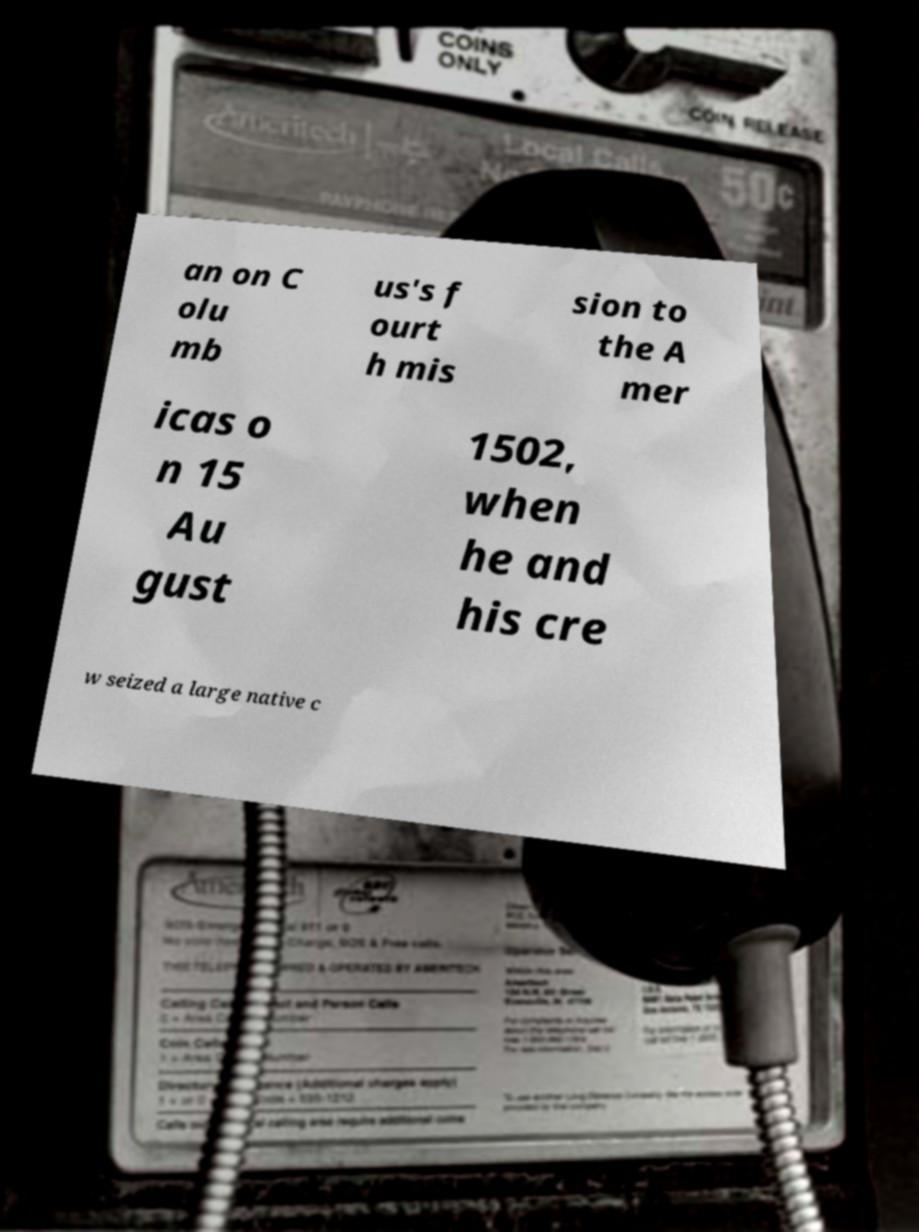For documentation purposes, I need the text within this image transcribed. Could you provide that? an on C olu mb us's f ourt h mis sion to the A mer icas o n 15 Au gust 1502, when he and his cre w seized a large native c 